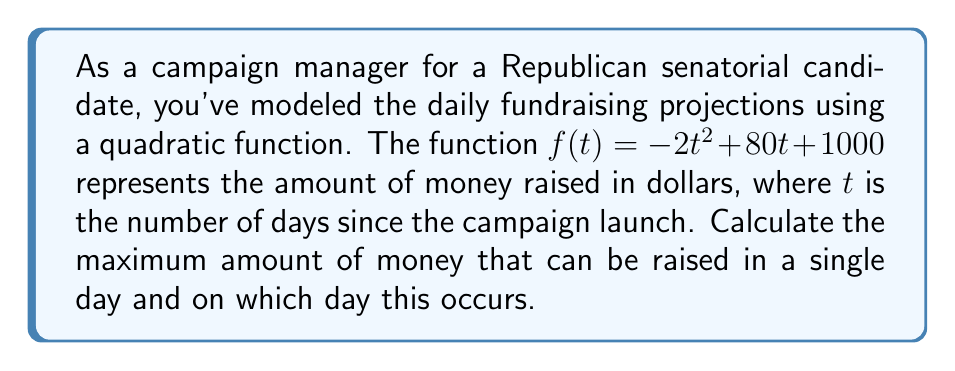Could you help me with this problem? To solve this problem, we need to find the vertex of the quadratic function, which represents the maximum point of the parabola. The quadratic function is in the form $f(t) = at^2 + bt + c$, where:

$a = -2$
$b = 80$
$c = 1000$

To find the vertex, we use the formula: $t = -\frac{b}{2a}$

$$t = -\frac{80}{2(-2)} = -\frac{80}{-4} = 20$$

This means the maximum occurs 20 days after the campaign launch.

To find the maximum amount raised, we substitute $t = 20$ into the original function:

$$\begin{align}
f(20) &= -2(20)^2 + 80(20) + 1000 \\
&= -2(400) + 1600 + 1000 \\
&= -800 + 1600 + 1000 \\
&= 1800
\end{align}$$

Therefore, the maximum amount raised in a single day is $1800.
Answer: The maximum amount of money that can be raised in a single day is $1800, occurring 20 days after the campaign launch. 